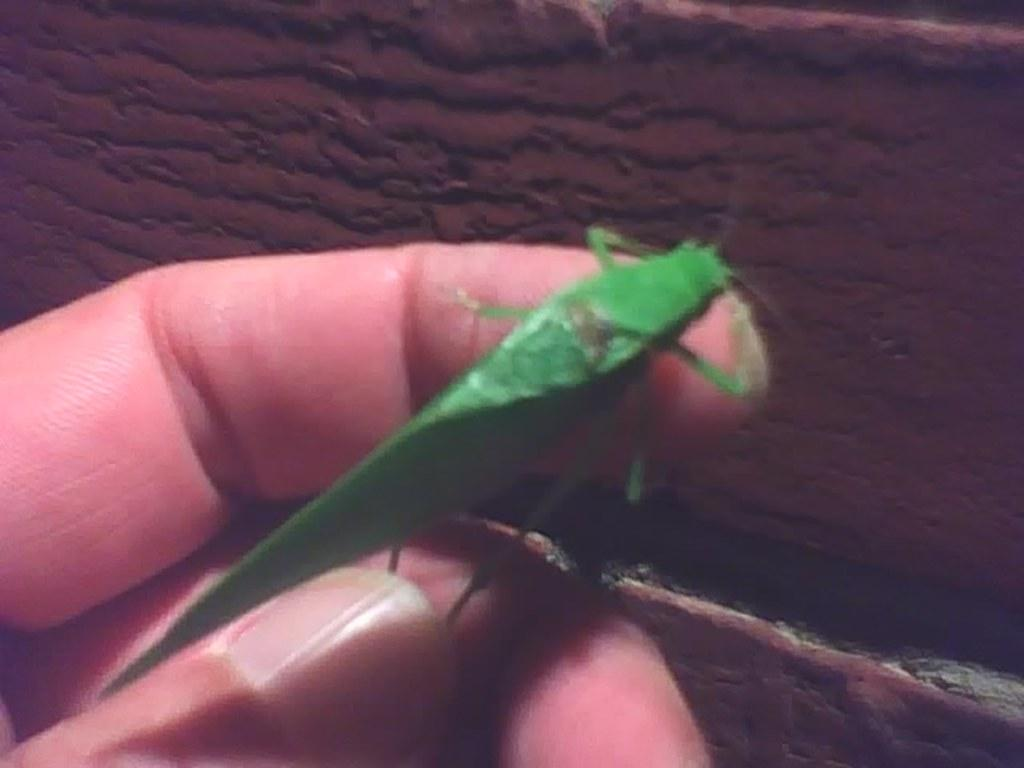What is the person's fingers holding in the image? The person's fingers are holding an insect in the image. What can be observed about the background of the image? The background of the image is brown in color. What type of coil is visible in the image? There is no coil present in the image. How many wings can be seen on the insect in the image? The image only shows the person's fingers holding the insect, so it is not possible to determine the number of wings from the image. 